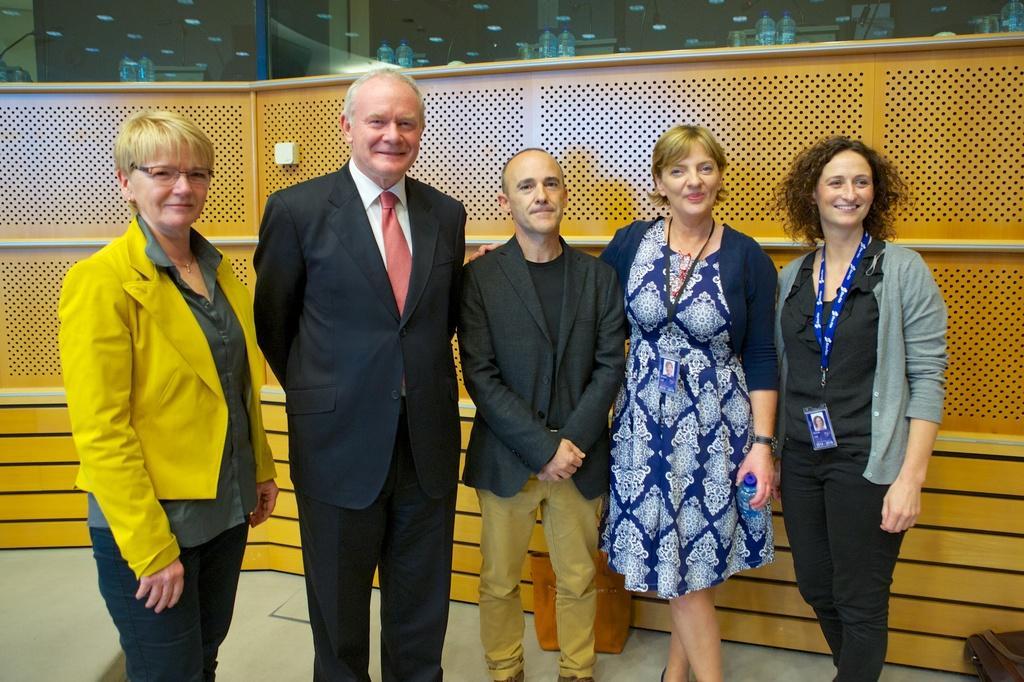Can you describe this image briefly? In this image there are a few people standing with a smile on their face, behind them there is a wooden wall, behind the wooden wall there is a glass. 